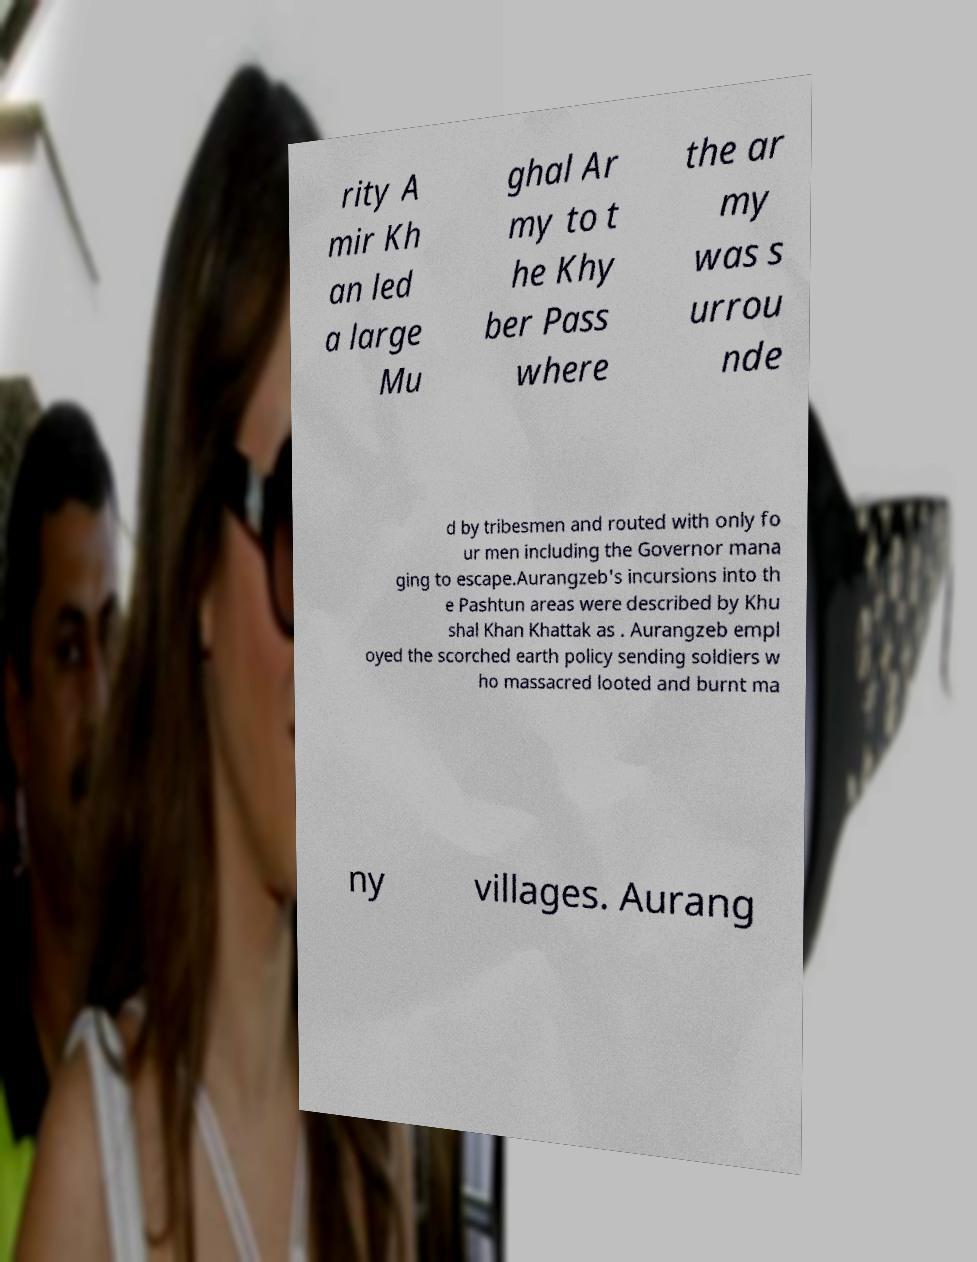What messages or text are displayed in this image? I need them in a readable, typed format. rity A mir Kh an led a large Mu ghal Ar my to t he Khy ber Pass where the ar my was s urrou nde d by tribesmen and routed with only fo ur men including the Governor mana ging to escape.Aurangzeb's incursions into th e Pashtun areas were described by Khu shal Khan Khattak as . Aurangzeb empl oyed the scorched earth policy sending soldiers w ho massacred looted and burnt ma ny villages. Aurang 